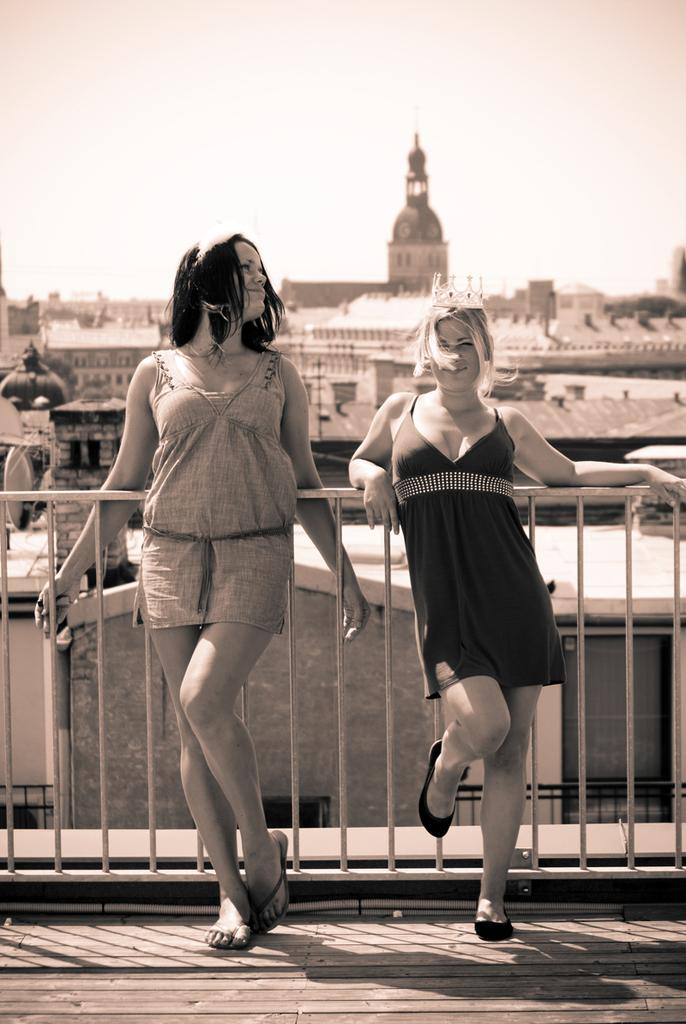How many people are in the image? There are two ladies in the image. What are the ladies doing in the image? The ladies are standing in front of the fencing. What can be seen in the background of the image? There are buildings and houses in the background of the image. What type of plastic material can be seen in the image? There is no plastic material present in the image. What is the purpose of the alarm in the image? There is no alarm present in the image. 